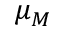Convert formula to latex. <formula><loc_0><loc_0><loc_500><loc_500>\mu _ { M }</formula> 